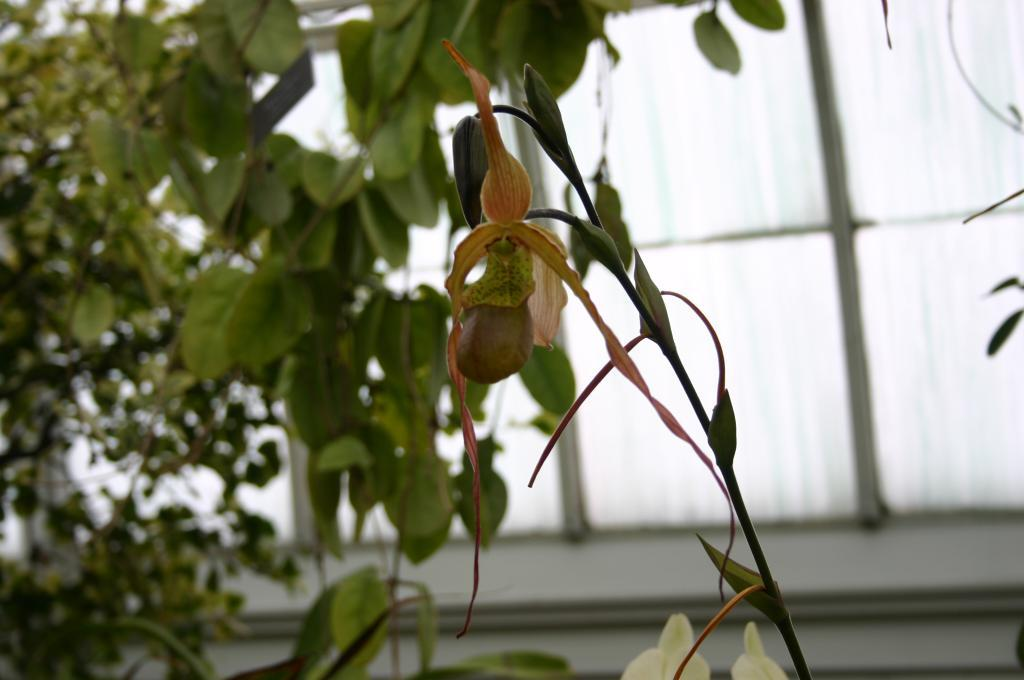What type of plant is in the front of the image? There is a plant with seeds in the front of the image. Can you describe the plant in the background? There is another plant in the background of the image. What can be seen through the window in the background? Unfortunately, the facts provided do not mention anything visible through the window. What color are the eyes of the banana in the image? There is no banana present in the image, and therefore no eyes to describe. 